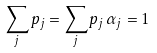<formula> <loc_0><loc_0><loc_500><loc_500>\sum _ { j } p _ { j } = \sum _ { j } p _ { j } \, \alpha _ { j } = 1</formula> 